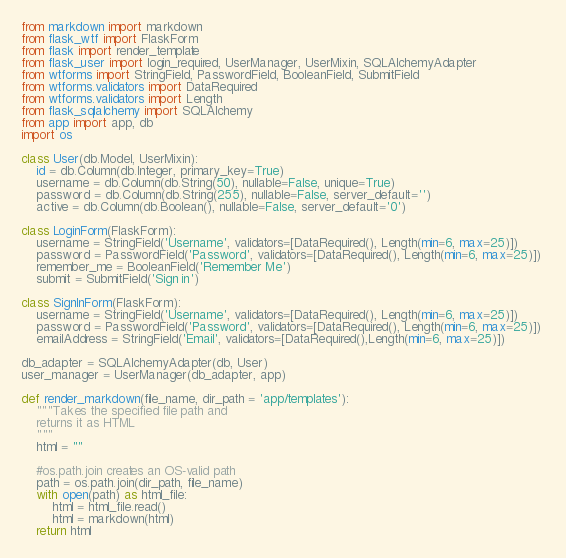Convert code to text. <code><loc_0><loc_0><loc_500><loc_500><_Python_>from markdown import markdown
from flask_wtf import FlaskForm
from flask import render_template
from flask_user import login_required, UserManager, UserMixin, SQLAlchemyAdapter
from wtforms import StringField, PasswordField, BooleanField, SubmitField
from wtforms.validators import DataRequired
from wtforms.validators import Length
from flask_sqlalchemy import SQLAlchemy
from app import app, db
import os

class User(db.Model, UserMixin):
    id = db.Column(db.Integer, primary_key=True)
    username = db.Column(db.String(50), nullable=False, unique=True)
    password = db.Column(db.String(255), nullable=False, server_default='')
    active = db.Column(db.Boolean(), nullable=False, server_default='0')

class LoginForm(FlaskForm):
    username = StringField('Username', validators=[DataRequired(), Length(min=6, max=25)])
    password = PasswordField('Password', validators=[DataRequired(), Length(min=6, max=25)])
    remember_me = BooleanField('Remember Me')
    submit = SubmitField('Sign in')

class SignInForm(FlaskForm):
    username = StringField('Username', validators=[DataRequired(), Length(min=6, max=25)])
    password = PasswordField('Password', validators=[DataRequired(), Length(min=6, max=25)]) 
    emailAddress = StringField('Email', validators=[DataRequired(),Length(min=6, max=25)])

db_adapter = SQLAlchemyAdapter(db, User)
user_manager = UserManager(db_adapter, app)

def render_markdown(file_name, dir_path = 'app/templates'):
    """Takes the specified file path and
    returns it as HTML
    """
    html = ""

    #os.path.join creates an OS-valid path
    path = os.path.join(dir_path, file_name)
    with open(path) as html_file:
        html = html_file.read()
        html = markdown(html)
    return html


</code> 